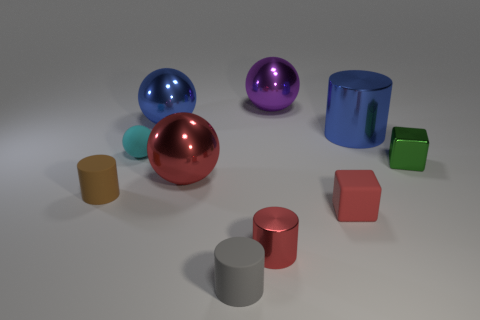What size is the blue metal thing that is the same shape as the tiny gray thing? The blue metal object, which shares its cylindrical shape with the smaller gray cylinder, is considerably larger. While the exact dimensions are not provided, it can be visually assessed to be about five times taller and wider than the small gray counterpart. 